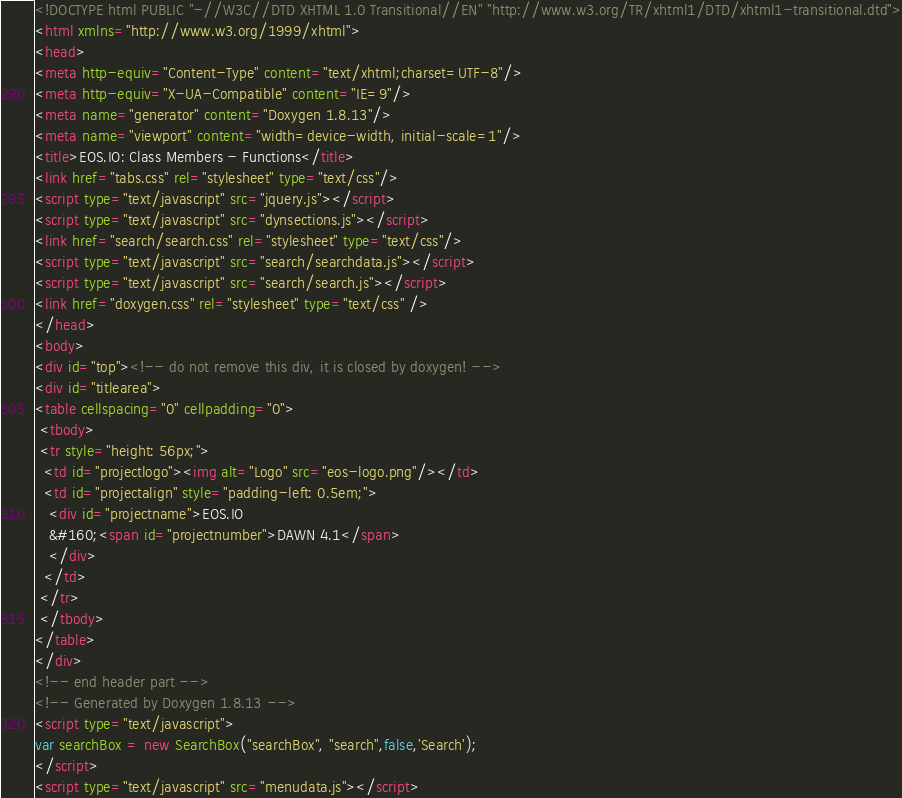Convert code to text. <code><loc_0><loc_0><loc_500><loc_500><_HTML_><!DOCTYPE html PUBLIC "-//W3C//DTD XHTML 1.0 Transitional//EN" "http://www.w3.org/TR/xhtml1/DTD/xhtml1-transitional.dtd">
<html xmlns="http://www.w3.org/1999/xhtml">
<head>
<meta http-equiv="Content-Type" content="text/xhtml;charset=UTF-8"/>
<meta http-equiv="X-UA-Compatible" content="IE=9"/>
<meta name="generator" content="Doxygen 1.8.13"/>
<meta name="viewport" content="width=device-width, initial-scale=1"/>
<title>EOS.IO: Class Members - Functions</title>
<link href="tabs.css" rel="stylesheet" type="text/css"/>
<script type="text/javascript" src="jquery.js"></script>
<script type="text/javascript" src="dynsections.js"></script>
<link href="search/search.css" rel="stylesheet" type="text/css"/>
<script type="text/javascript" src="search/searchdata.js"></script>
<script type="text/javascript" src="search/search.js"></script>
<link href="doxygen.css" rel="stylesheet" type="text/css" />
</head>
<body>
<div id="top"><!-- do not remove this div, it is closed by doxygen! -->
<div id="titlearea">
<table cellspacing="0" cellpadding="0">
 <tbody>
 <tr style="height: 56px;">
  <td id="projectlogo"><img alt="Logo" src="eos-logo.png"/></td>
  <td id="projectalign" style="padding-left: 0.5em;">
   <div id="projectname">EOS.IO
   &#160;<span id="projectnumber">DAWN 4.1</span>
   </div>
  </td>
 </tr>
 </tbody>
</table>
</div>
<!-- end header part -->
<!-- Generated by Doxygen 1.8.13 -->
<script type="text/javascript">
var searchBox = new SearchBox("searchBox", "search",false,'Search');
</script>
<script type="text/javascript" src="menudata.js"></script></code> 